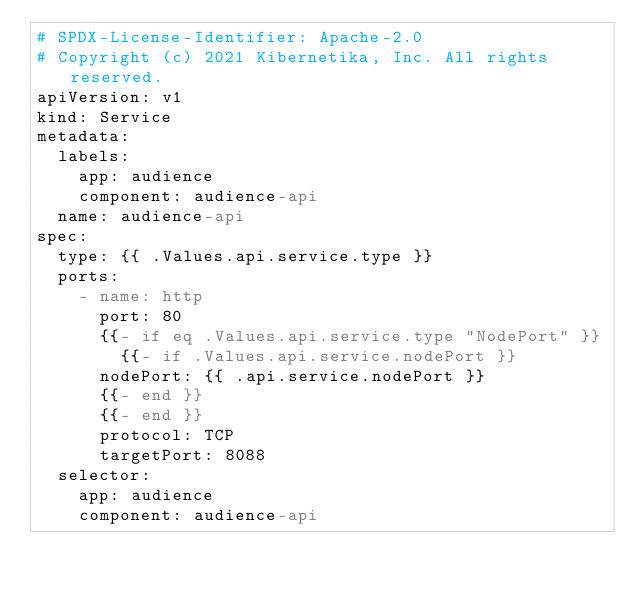<code> <loc_0><loc_0><loc_500><loc_500><_YAML_># SPDX-License-Identifier: Apache-2.0
# Copyright (c) 2021 Kibernetika, Inc. All rights reserved.
apiVersion: v1
kind: Service
metadata:
  labels:
    app: audience
    component: audience-api
  name: audience-api
spec:
  type: {{ .Values.api.service.type }}
  ports:
    - name: http
      port: 80
      {{- if eq .Values.api.service.type "NodePort" }}
        {{- if .Values.api.service.nodePort }}
      nodePort: {{ .api.service.nodePort }}
      {{- end }}
      {{- end }}
      protocol: TCP
      targetPort: 8088
  selector:
    app: audience
    component: audience-api
</code> 